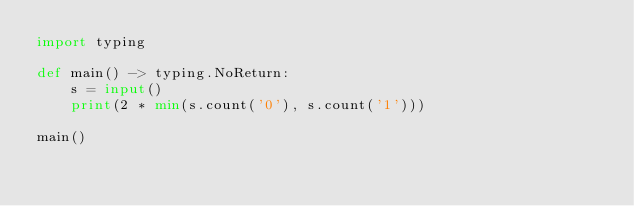<code> <loc_0><loc_0><loc_500><loc_500><_Python_>import typing 

def main() -> typing.NoReturn:
    s = input()
    print(2 * min(s.count('0'), s.count('1')))

main()</code> 